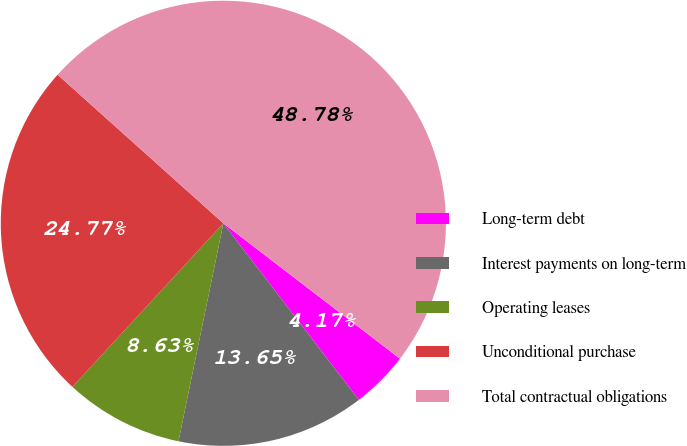Convert chart to OTSL. <chart><loc_0><loc_0><loc_500><loc_500><pie_chart><fcel>Long-term debt<fcel>Interest payments on long-term<fcel>Operating leases<fcel>Unconditional purchase<fcel>Total contractual obligations<nl><fcel>4.17%<fcel>13.65%<fcel>8.63%<fcel>24.77%<fcel>48.78%<nl></chart> 